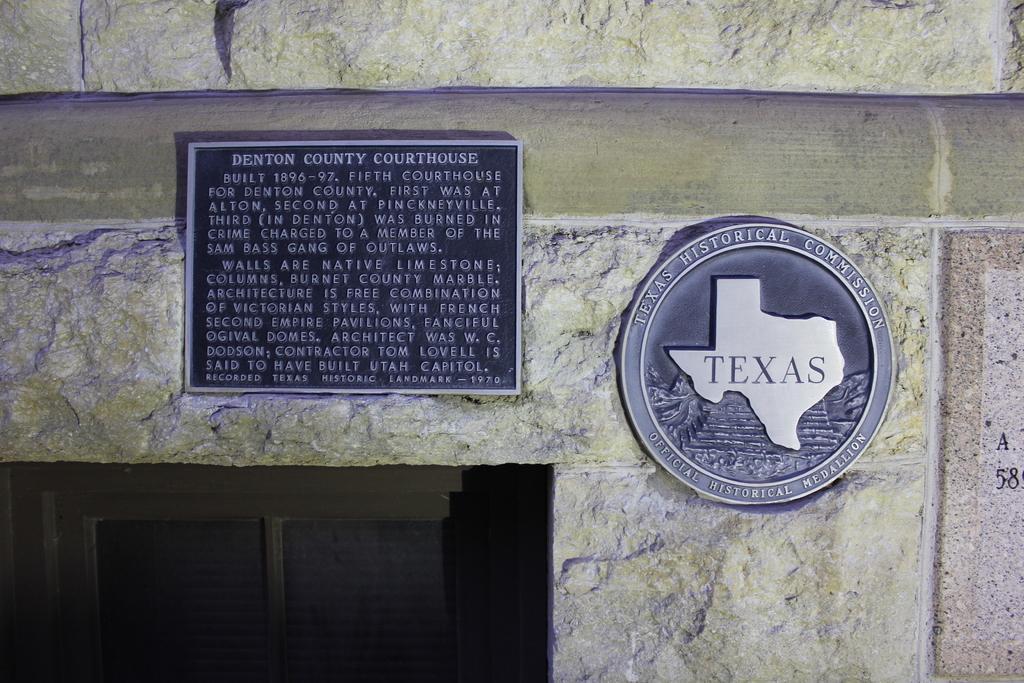Can you describe this image briefly? In this picture we can see some boards to the wall and we can see some wooden thing in between the wall. 